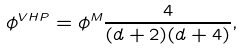Convert formula to latex. <formula><loc_0><loc_0><loc_500><loc_500>\phi ^ { V H P } = \phi ^ { M } \frac { 4 } { ( d + 2 ) ( d + 4 ) } ,</formula> 